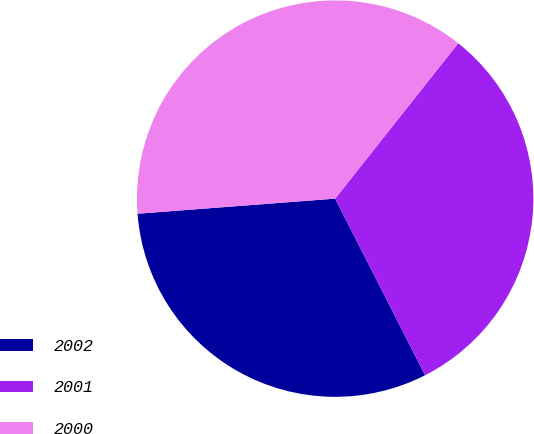<chart> <loc_0><loc_0><loc_500><loc_500><pie_chart><fcel>2002<fcel>2001<fcel>2000<nl><fcel>31.28%<fcel>31.84%<fcel>36.87%<nl></chart> 